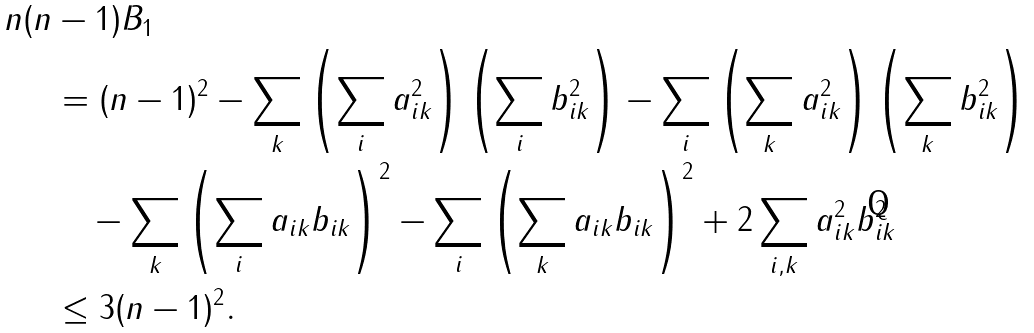<formula> <loc_0><loc_0><loc_500><loc_500>n ( n & - 1 ) B _ { 1 } \\ & = ( n - 1 ) ^ { 2 } - \sum _ { k } \left ( \sum _ { i } a _ { i k } ^ { 2 } \right ) \left ( \sum _ { i } b _ { i k } ^ { 2 } \right ) - \sum _ { i } \left ( \sum _ { k } a _ { i k } ^ { 2 } \right ) \left ( \sum _ { k } b _ { i k } ^ { 2 } \right ) \\ & \quad - \sum _ { k } \left ( \sum _ { i } a _ { i k } b _ { i k } \right ) ^ { 2 } - \sum _ { i } \left ( \sum _ { k } a _ { i k } b _ { i k } \right ) ^ { 2 } + 2 \sum _ { i , k } a _ { i k } ^ { 2 } b _ { i k } ^ { 2 } \\ & \leq 3 ( n - 1 ) ^ { 2 } .</formula> 